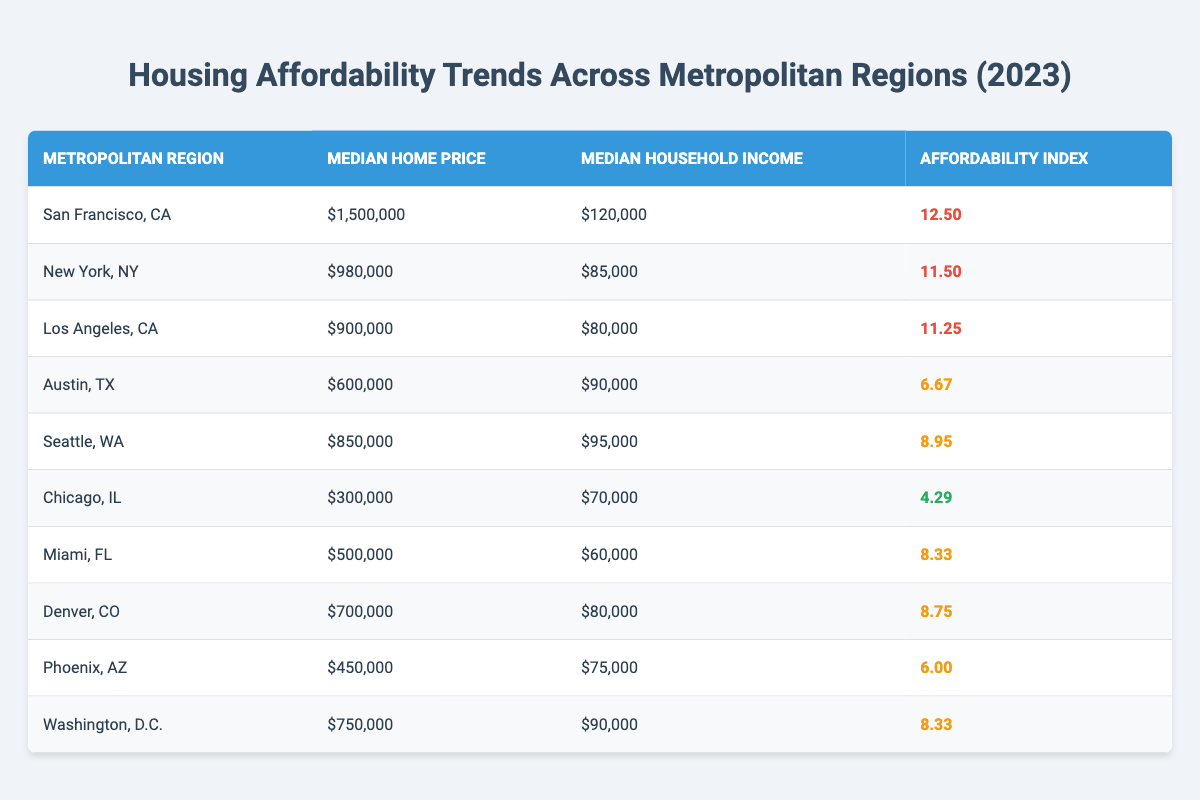What is the median home price in San Francisco, CA? According to the table, the median home price for San Francisco, CA is listed directly as $1,500,000.
Answer: $1,500,000 Which metropolitan region has the highest affordability index? The highest affordability index in the table is for San Francisco, CA with an index of 12.5.
Answer: San Francisco, CA What is the median household income in New York, NY? The table shows that the median household income for New York, NY is $85,000.
Answer: $85,000 Calculate the difference in median home price between Los Angeles, CA and Chicago, IL. The median home price for Los Angeles, CA is $900,000, and for Chicago, IL, it is $300,000. The difference is $900,000 - $300,000 = $600,000.
Answer: $600,000 Is the affordability index for Miami, FL higher than that of Phoenix, AZ? The affordability index for Miami, FL is 8.33, while for Phoenix, AZ it is 6.00. Since 8.33 > 6.00, Miami, FL has a higher index.
Answer: Yes What is the average median home price of the top three most expensive metropolitan regions? The top three regions by median home price are San Francisco ($1,500,000), New York ($980,000), and Los Angeles ($900,000). Their average is (1,500,000 + 980,000 + 900,000) / 3 = $1,126,667.
Answer: $1,126,667 What is the lowest affordability index in the table and which region does it belong to? The lowest affordability index in the table is 4.29, which belongs to Chicago, IL.
Answer: Chicago, IL How many metropolitan regions have an affordability index above 8? The regions with an index above 8 are San Francisco (12.5), New York (11.5), Los Angeles (11.25), Seattle (8.95), Miami (8.33), Denver (8.75), Washington, D.C. (8.33). This totals 7 regions.
Answer: 7 If we compare the median household incomes of Seattle, WA and Denver, CO, which is higher? Seattle has a median household income of $95,000, while Denver has an income of $80,000. Since $95,000 > $80,000, Seattle has the higher income.
Answer: Seattle, WA What is the total median household income of the regions with an affordability index less than 7? The regions with an index less than 7 are Austin (90,000), Chicago (70,000), and Phoenix (75,000). The total is 90,000 + 70,000 + 75,000 = 235,000.
Answer: $235,000 Which metropolitan region has a median home price closest to the national average? The provided data does not include a national average, thus the question cannot be answered accurately based on the table alone.
Answer: Not applicable 